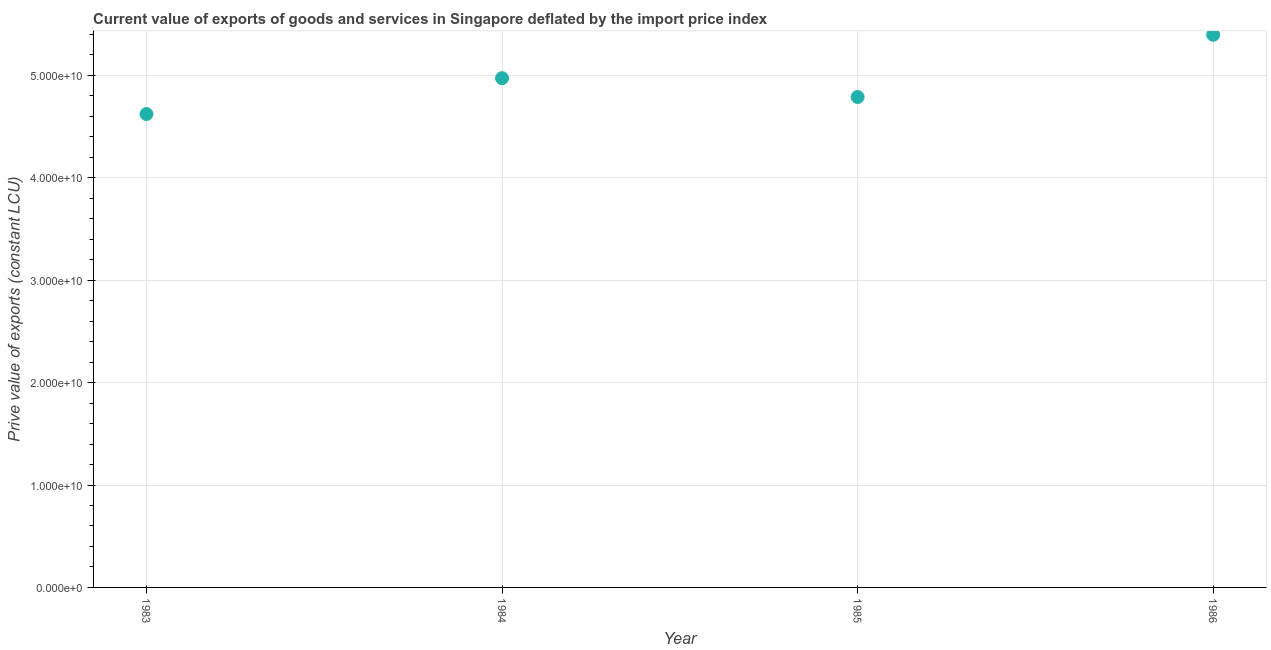What is the price value of exports in 1983?
Your answer should be very brief. 4.62e+1. Across all years, what is the maximum price value of exports?
Offer a very short reply. 5.40e+1. Across all years, what is the minimum price value of exports?
Make the answer very short. 4.62e+1. In which year was the price value of exports minimum?
Keep it short and to the point. 1983. What is the sum of the price value of exports?
Provide a short and direct response. 1.98e+11. What is the difference between the price value of exports in 1983 and 1985?
Give a very brief answer. -1.66e+09. What is the average price value of exports per year?
Give a very brief answer. 4.94e+1. What is the median price value of exports?
Offer a terse response. 4.88e+1. In how many years, is the price value of exports greater than 44000000000 LCU?
Offer a terse response. 4. Do a majority of the years between 1986 and 1983 (inclusive) have price value of exports greater than 42000000000 LCU?
Your answer should be very brief. Yes. What is the ratio of the price value of exports in 1984 to that in 1985?
Offer a very short reply. 1.04. Is the price value of exports in 1984 less than that in 1985?
Provide a succinct answer. No. What is the difference between the highest and the second highest price value of exports?
Your answer should be very brief. 4.24e+09. What is the difference between the highest and the lowest price value of exports?
Your answer should be very brief. 7.74e+09. In how many years, is the price value of exports greater than the average price value of exports taken over all years?
Provide a short and direct response. 2. Does the price value of exports monotonically increase over the years?
Your answer should be compact. No. How many dotlines are there?
Ensure brevity in your answer.  1. How many years are there in the graph?
Give a very brief answer. 4. What is the difference between two consecutive major ticks on the Y-axis?
Offer a terse response. 1.00e+1. What is the title of the graph?
Make the answer very short. Current value of exports of goods and services in Singapore deflated by the import price index. What is the label or title of the Y-axis?
Offer a very short reply. Prive value of exports (constant LCU). What is the Prive value of exports (constant LCU) in 1983?
Your answer should be very brief. 4.62e+1. What is the Prive value of exports (constant LCU) in 1984?
Offer a very short reply. 4.97e+1. What is the Prive value of exports (constant LCU) in 1985?
Your answer should be compact. 4.79e+1. What is the Prive value of exports (constant LCU) in 1986?
Provide a short and direct response. 5.40e+1. What is the difference between the Prive value of exports (constant LCU) in 1983 and 1984?
Your answer should be very brief. -3.50e+09. What is the difference between the Prive value of exports (constant LCU) in 1983 and 1985?
Provide a short and direct response. -1.66e+09. What is the difference between the Prive value of exports (constant LCU) in 1983 and 1986?
Offer a terse response. -7.74e+09. What is the difference between the Prive value of exports (constant LCU) in 1984 and 1985?
Provide a succinct answer. 1.84e+09. What is the difference between the Prive value of exports (constant LCU) in 1984 and 1986?
Give a very brief answer. -4.24e+09. What is the difference between the Prive value of exports (constant LCU) in 1985 and 1986?
Your response must be concise. -6.08e+09. What is the ratio of the Prive value of exports (constant LCU) in 1983 to that in 1984?
Provide a succinct answer. 0.93. What is the ratio of the Prive value of exports (constant LCU) in 1983 to that in 1986?
Offer a terse response. 0.86. What is the ratio of the Prive value of exports (constant LCU) in 1984 to that in 1985?
Offer a very short reply. 1.04. What is the ratio of the Prive value of exports (constant LCU) in 1984 to that in 1986?
Give a very brief answer. 0.92. What is the ratio of the Prive value of exports (constant LCU) in 1985 to that in 1986?
Make the answer very short. 0.89. 